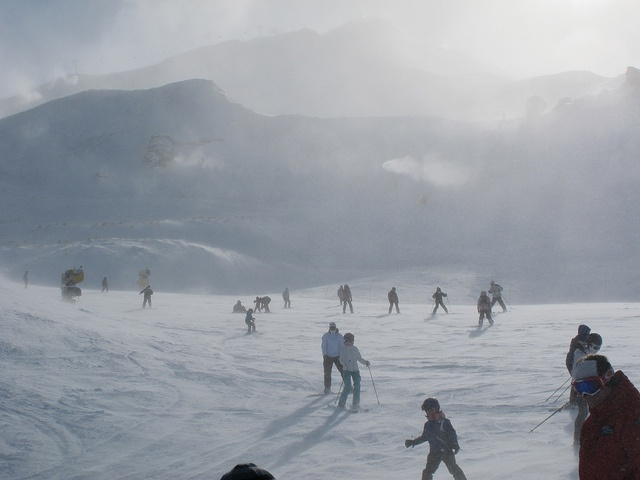Describe the objects in this image and their specific colors. I can see people in gray, black, and navy tones, people in gray, black, and darkgray tones, people in gray, darkgray, and purple tones, people in gray and black tones, and people in gray and black tones in this image. 